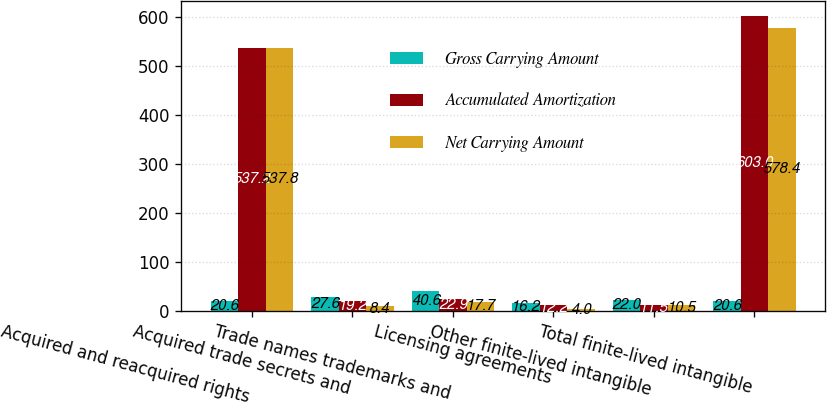Convert chart. <chart><loc_0><loc_0><loc_500><loc_500><stacked_bar_chart><ecel><fcel>Acquired and reacquired rights<fcel>Acquired trade secrets and<fcel>Trade names trademarks and<fcel>Licensing agreements<fcel>Other finite-lived intangible<fcel>Total finite-lived intangible<nl><fcel>Gross Carrying Amount<fcel>20.6<fcel>27.6<fcel>40.6<fcel>16.2<fcel>22<fcel>20.6<nl><fcel>Accumulated Amortization<fcel>537.2<fcel>19.2<fcel>22.9<fcel>12.2<fcel>11.5<fcel>603<nl><fcel>Net Carrying Amount<fcel>537.8<fcel>8.4<fcel>17.7<fcel>4<fcel>10.5<fcel>578.4<nl></chart> 